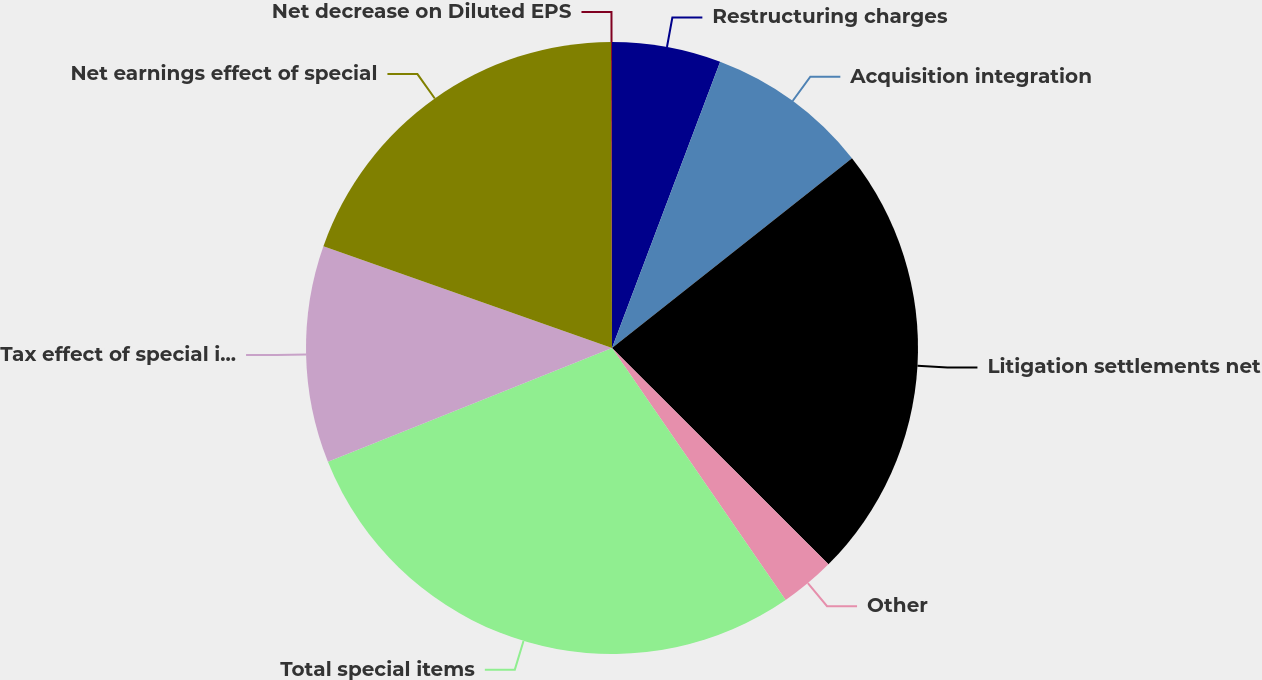Convert chart. <chart><loc_0><loc_0><loc_500><loc_500><pie_chart><fcel>Restructuring charges<fcel>Acquisition integration<fcel>Litigation settlements net<fcel>Other<fcel>Total special items<fcel>Tax effect of special items(1)<fcel>Net earnings effect of special<fcel>Net decrease on Diluted EPS<nl><fcel>5.75%<fcel>8.6%<fcel>23.15%<fcel>2.9%<fcel>28.55%<fcel>11.45%<fcel>19.56%<fcel>0.05%<nl></chart> 